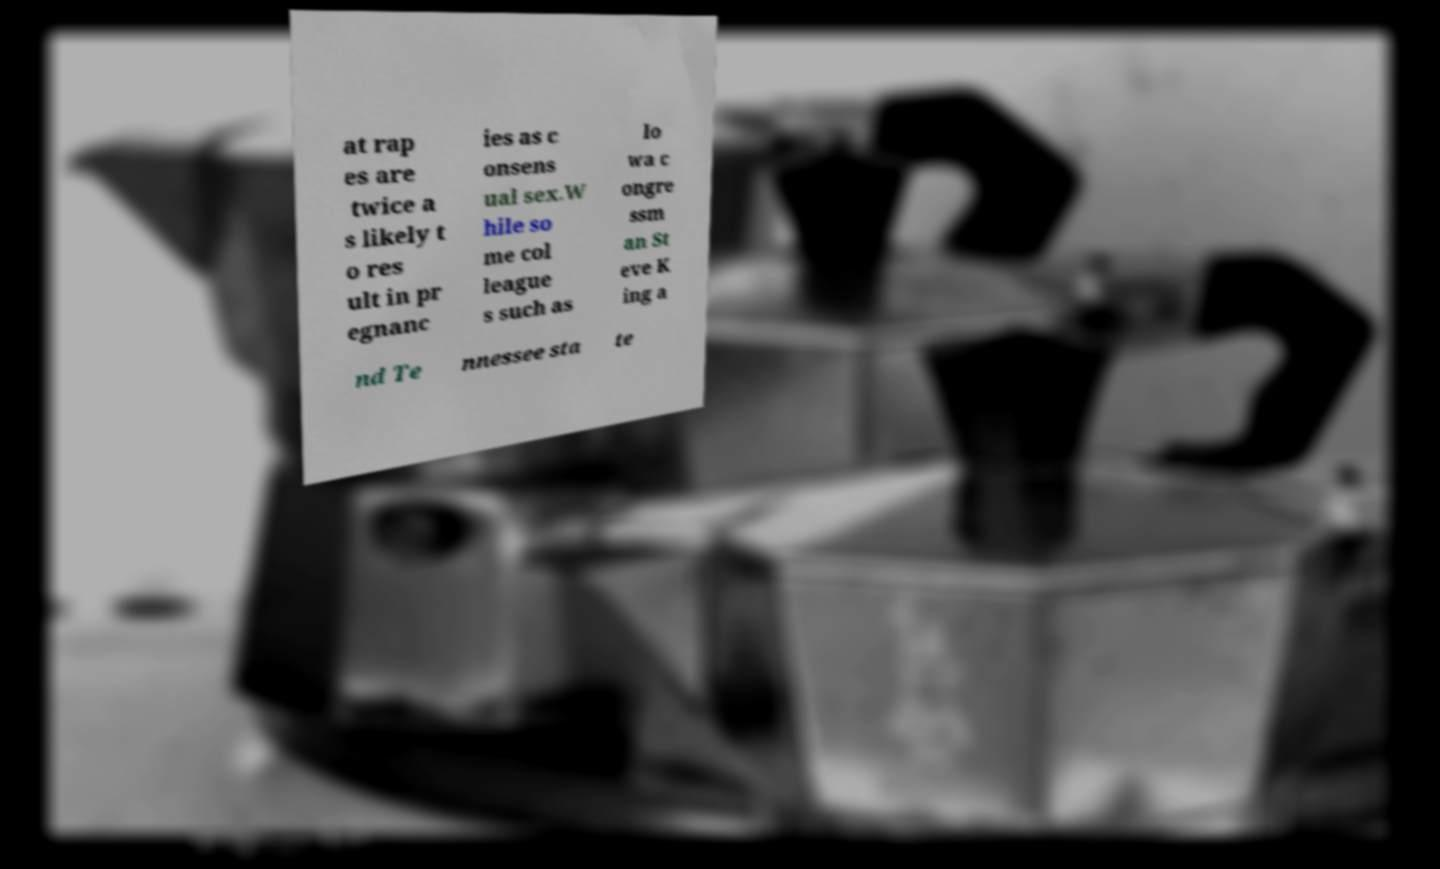I need the written content from this picture converted into text. Can you do that? at rap es are twice a s likely t o res ult in pr egnanc ies as c onsens ual sex.W hile so me col league s such as Io wa c ongre ssm an St eve K ing a nd Te nnessee sta te 